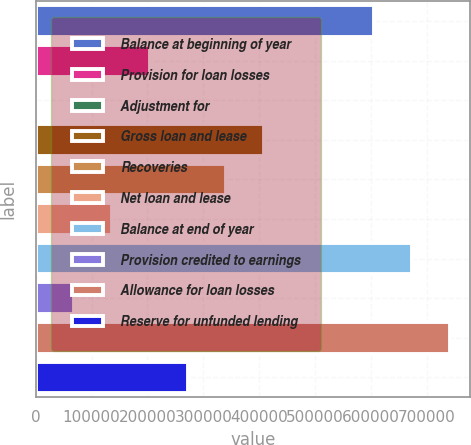Convert chart. <chart><loc_0><loc_0><loc_500><loc_500><bar_chart><fcel>Balance at beginning of year<fcel>Provision for loan losses<fcel>Adjustment for<fcel>Gross loan and lease<fcel>Recoveries<fcel>Net loan and lease<fcel>Balance at end of year<fcel>Provision credited to earnings<fcel>Allowance for loan losses<fcel>Reserve for unfunded lending<nl><fcel>604663<fcel>204269<fcel>5<fcel>408534<fcel>340446<fcel>136181<fcel>672751<fcel>68093.1<fcel>740839<fcel>272357<nl></chart> 